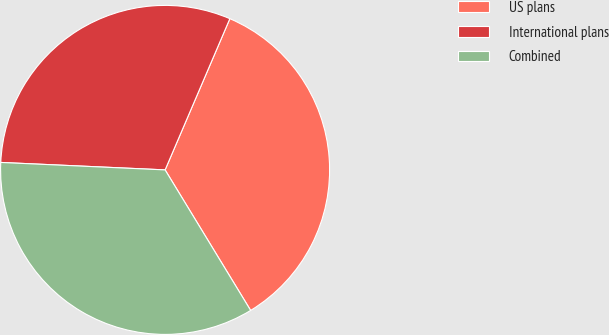Convert chart. <chart><loc_0><loc_0><loc_500><loc_500><pie_chart><fcel>US plans<fcel>International plans<fcel>Combined<nl><fcel>34.86%<fcel>30.72%<fcel>34.43%<nl></chart> 